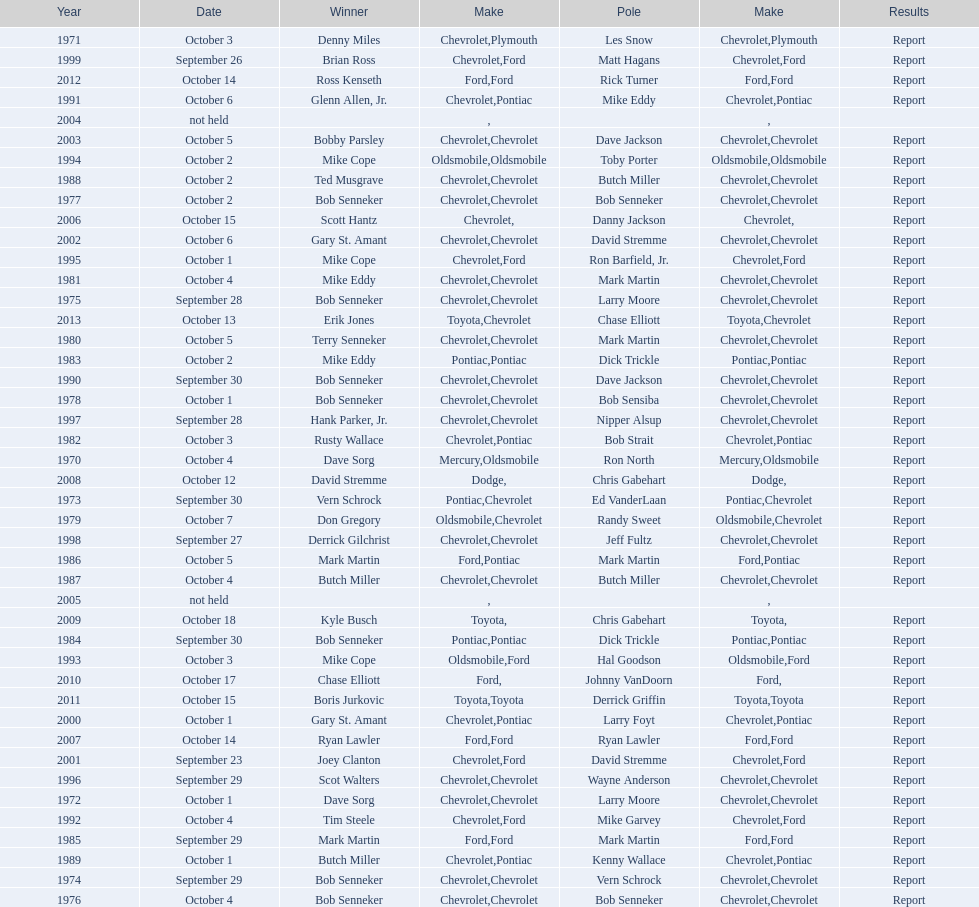Which month held the most winchester 400 races? October. 